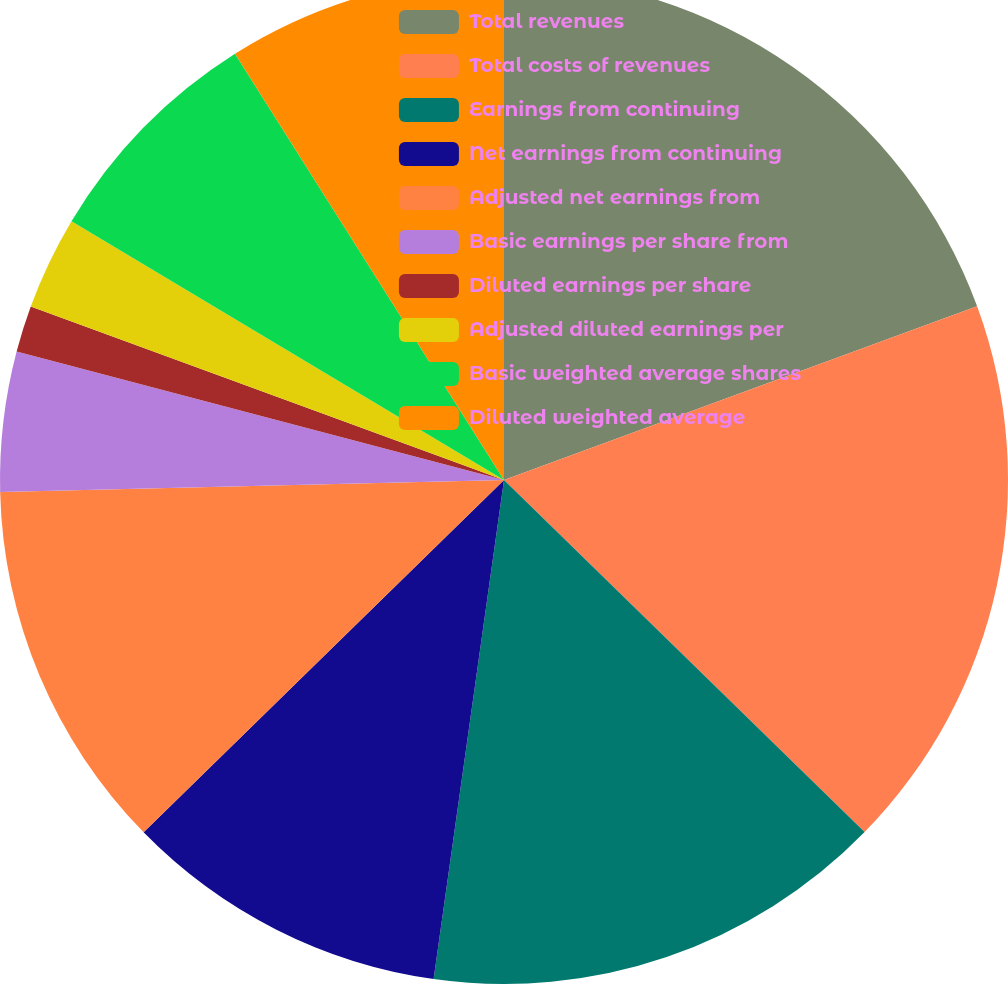<chart> <loc_0><loc_0><loc_500><loc_500><pie_chart><fcel>Total revenues<fcel>Total costs of revenues<fcel>Earnings from continuing<fcel>Net earnings from continuing<fcel>Adjusted net earnings from<fcel>Basic earnings per share from<fcel>Diluted earnings per share<fcel>Adjusted diluted earnings per<fcel>Basic weighted average shares<fcel>Diluted weighted average<nl><fcel>19.4%<fcel>17.91%<fcel>14.92%<fcel>10.45%<fcel>11.94%<fcel>4.48%<fcel>1.49%<fcel>2.99%<fcel>7.46%<fcel>8.96%<nl></chart> 